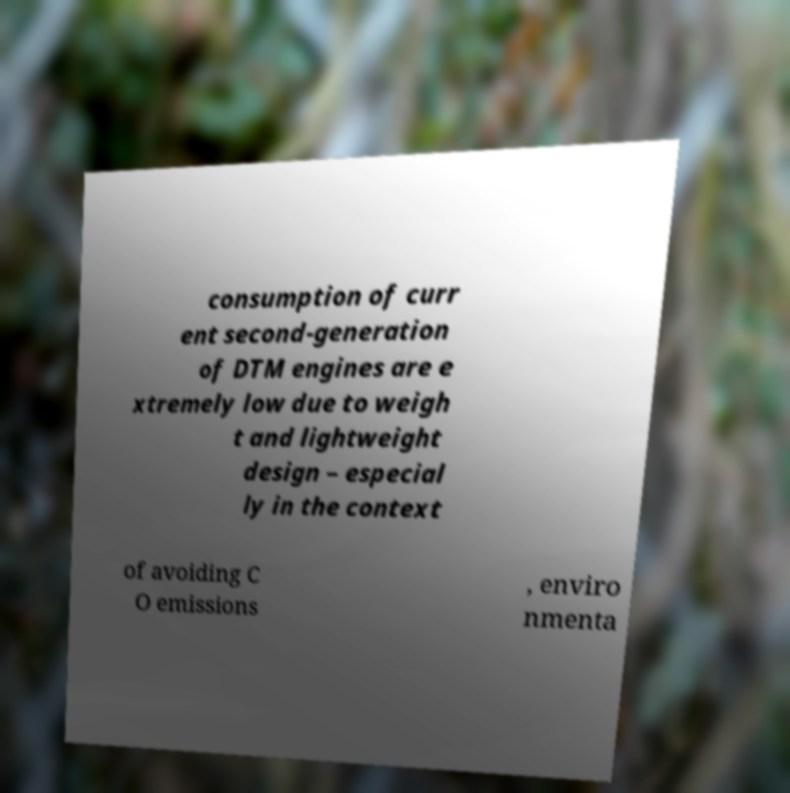Could you extract and type out the text from this image? consumption of curr ent second-generation of DTM engines are e xtremely low due to weigh t and lightweight design – especial ly in the context of avoiding C O emissions , enviro nmenta 